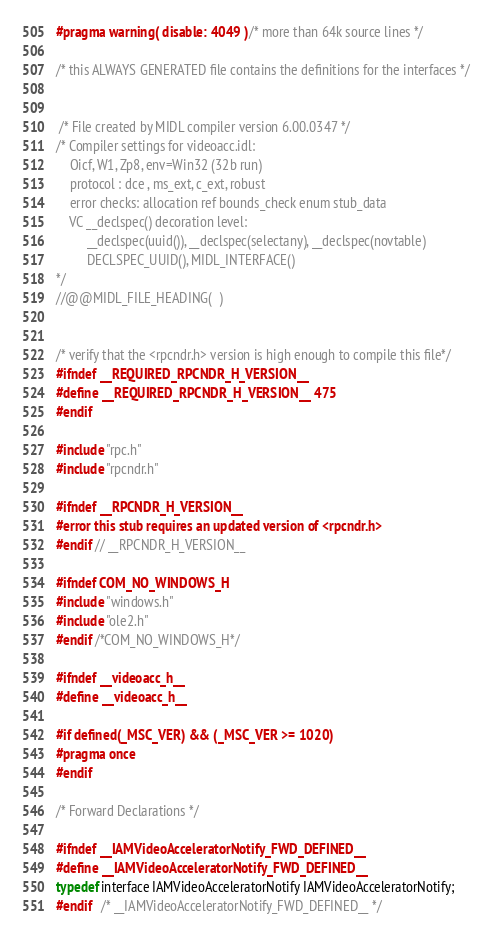<code> <loc_0><loc_0><loc_500><loc_500><_C_>
#pragma warning( disable: 4049 )  /* more than 64k source lines */

/* this ALWAYS GENERATED file contains the definitions for the interfaces */


 /* File created by MIDL compiler version 6.00.0347 */
/* Compiler settings for videoacc.idl:
    Oicf, W1, Zp8, env=Win32 (32b run)
    protocol : dce , ms_ext, c_ext, robust
    error checks: allocation ref bounds_check enum stub_data 
    VC __declspec() decoration level: 
         __declspec(uuid()), __declspec(selectany), __declspec(novtable)
         DECLSPEC_UUID(), MIDL_INTERFACE()
*/
//@@MIDL_FILE_HEADING(  )


/* verify that the <rpcndr.h> version is high enough to compile this file*/
#ifndef __REQUIRED_RPCNDR_H_VERSION__
#define __REQUIRED_RPCNDR_H_VERSION__ 475
#endif

#include "rpc.h"
#include "rpcndr.h"

#ifndef __RPCNDR_H_VERSION__
#error this stub requires an updated version of <rpcndr.h>
#endif // __RPCNDR_H_VERSION__

#ifndef COM_NO_WINDOWS_H
#include "windows.h"
#include "ole2.h"
#endif /*COM_NO_WINDOWS_H*/

#ifndef __videoacc_h__
#define __videoacc_h__

#if defined(_MSC_VER) && (_MSC_VER >= 1020)
#pragma once
#endif

/* Forward Declarations */ 

#ifndef __IAMVideoAcceleratorNotify_FWD_DEFINED__
#define __IAMVideoAcceleratorNotify_FWD_DEFINED__
typedef interface IAMVideoAcceleratorNotify IAMVideoAcceleratorNotify;
#endif 	/* __IAMVideoAcceleratorNotify_FWD_DEFINED__ */

</code> 